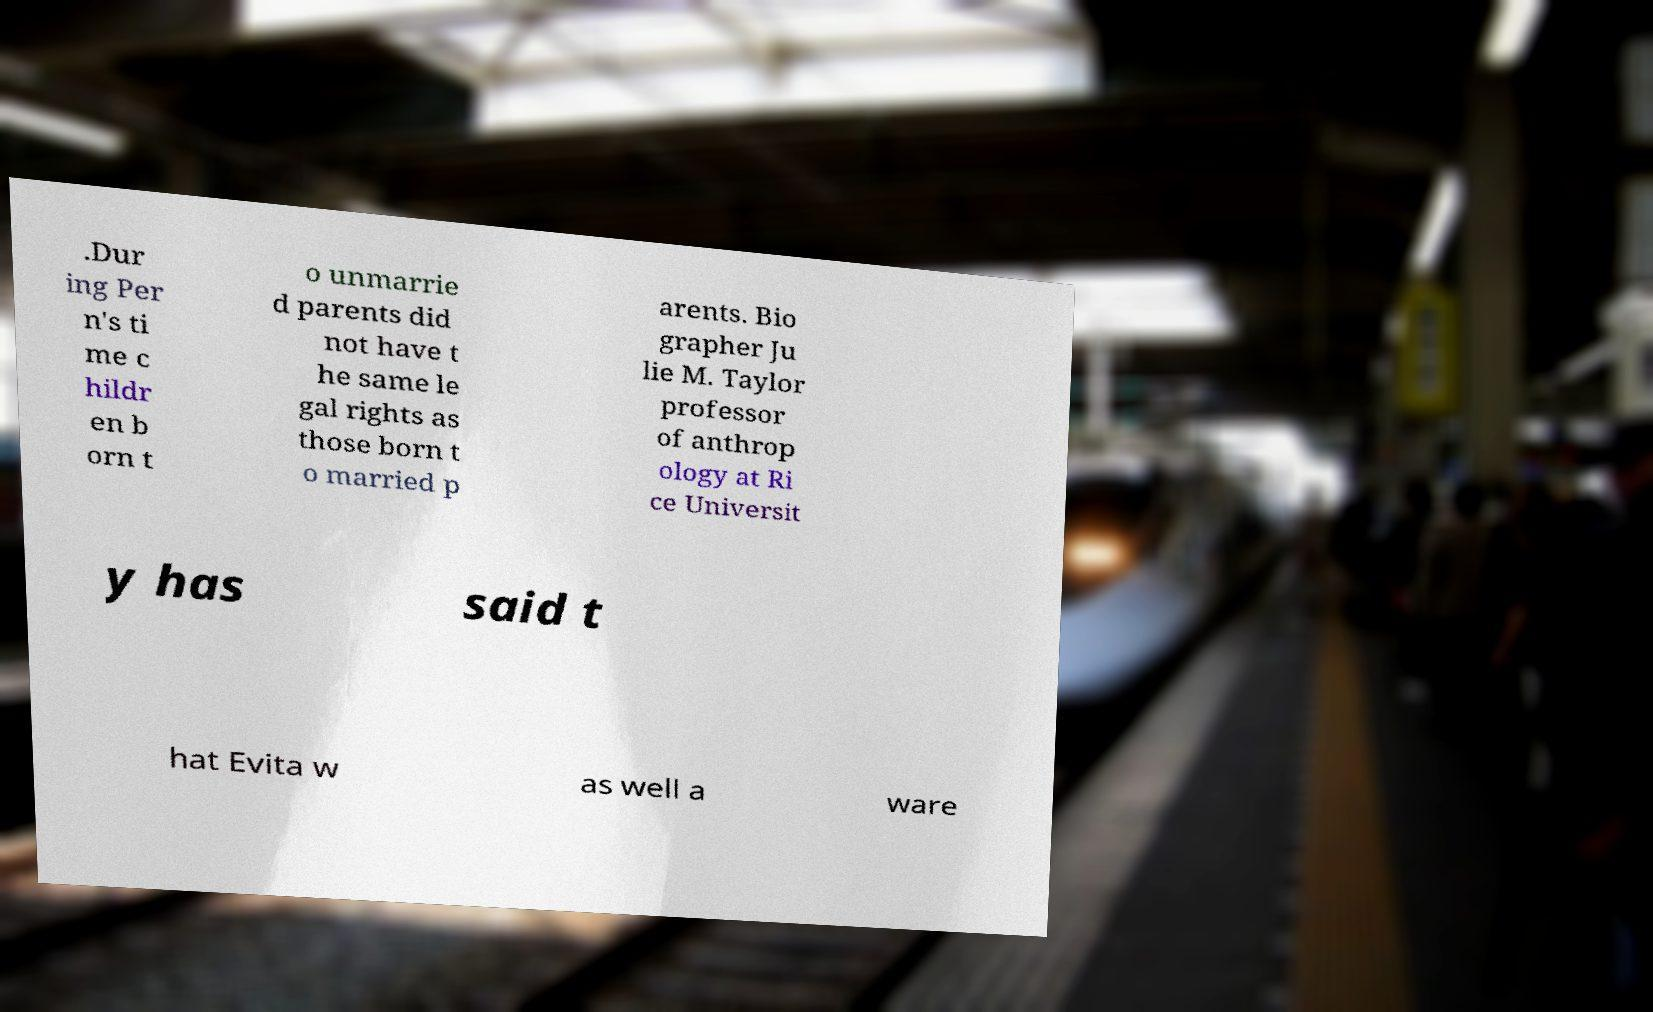Could you extract and type out the text from this image? .Dur ing Per n's ti me c hildr en b orn t o unmarrie d parents did not have t he same le gal rights as those born t o married p arents. Bio grapher Ju lie M. Taylor professor of anthrop ology at Ri ce Universit y has said t hat Evita w as well a ware 